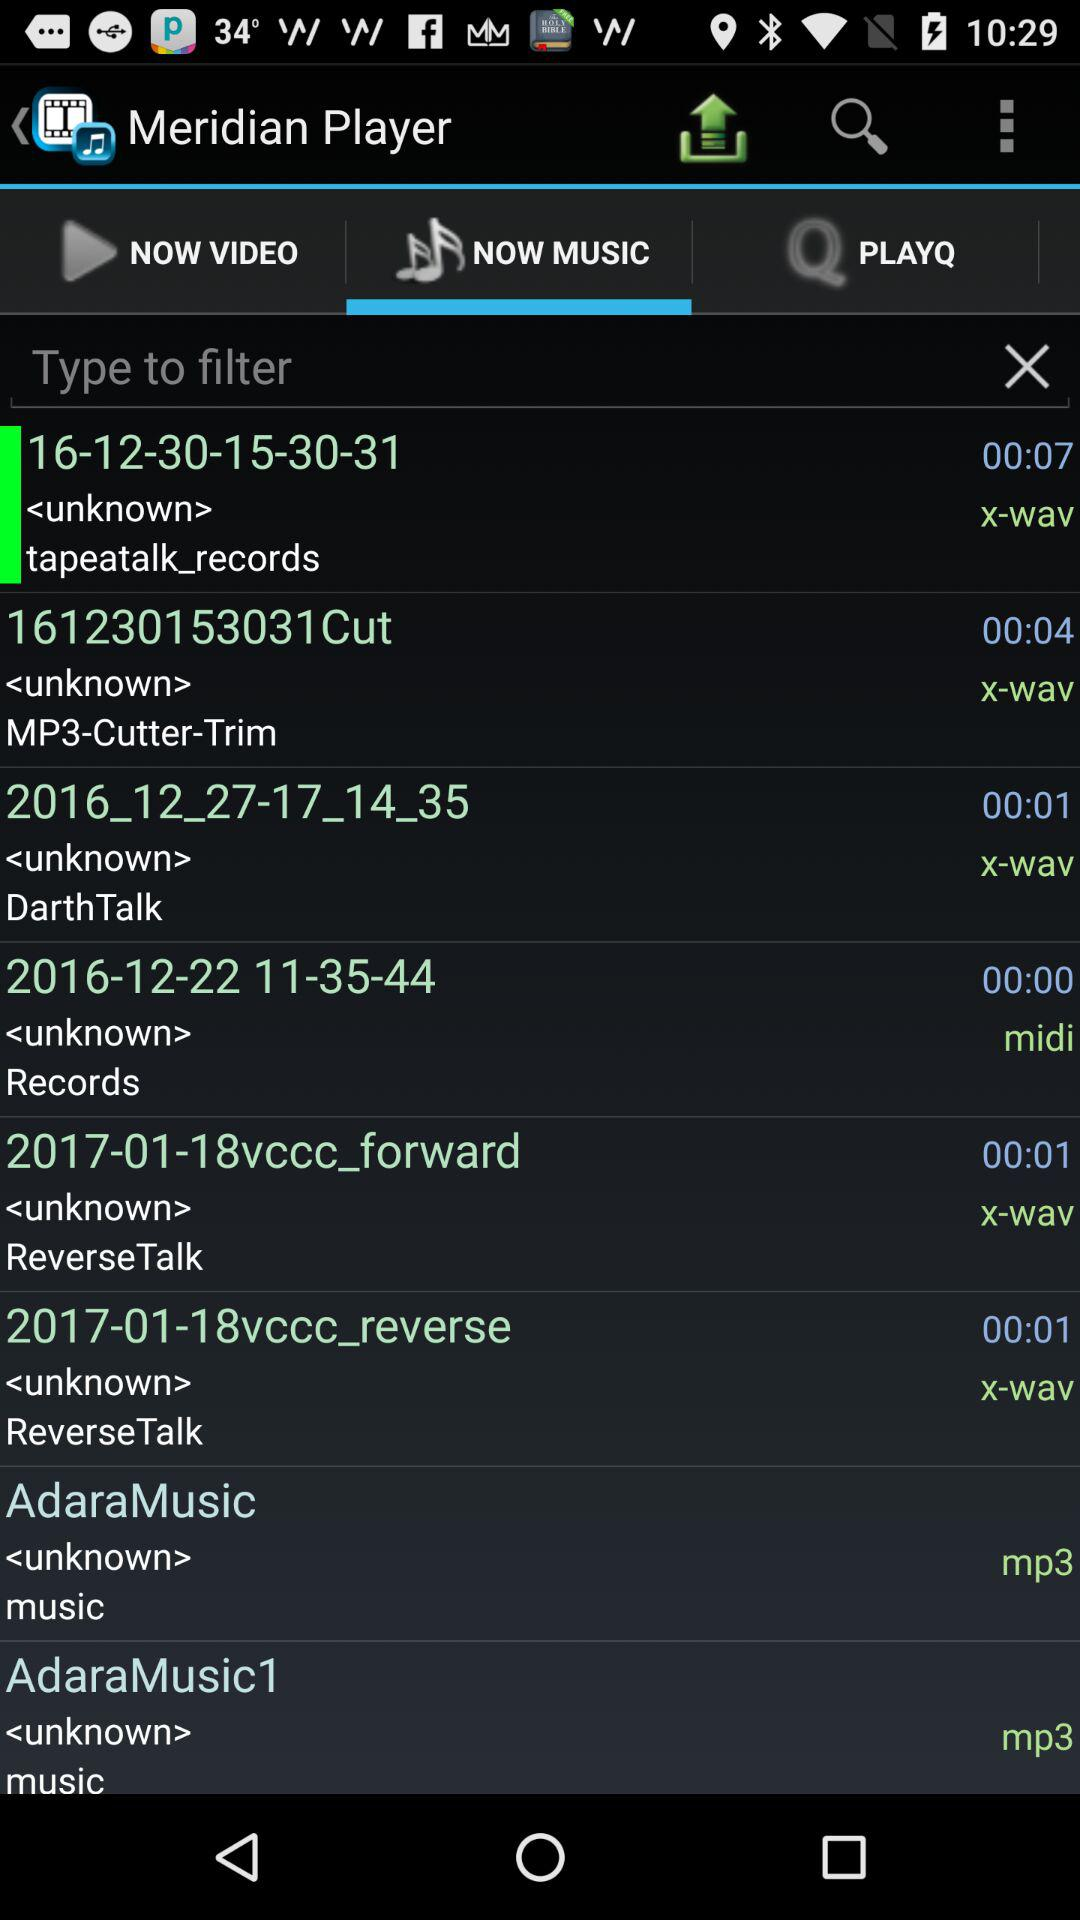Which tab is currently selected? The currently selected tab is "NOW MUSIC". 